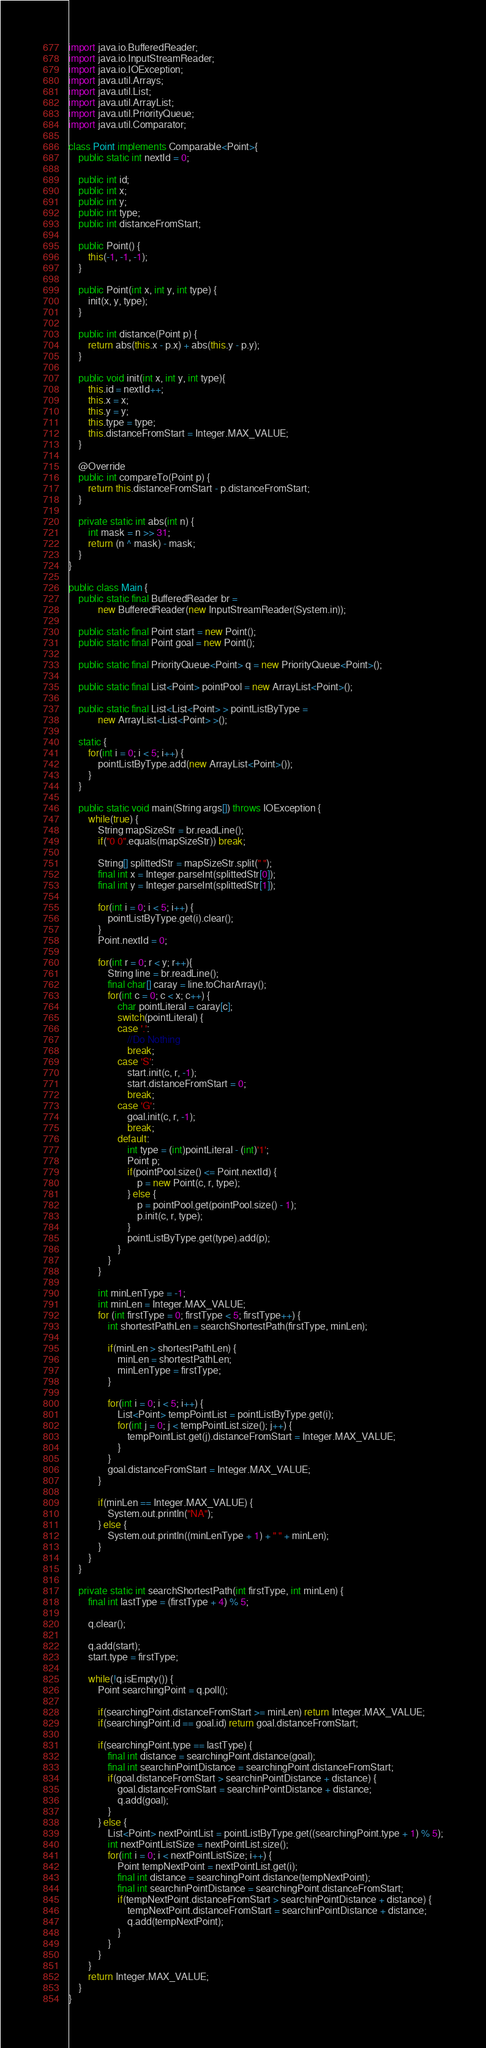Convert code to text. <code><loc_0><loc_0><loc_500><loc_500><_Java_>import java.io.BufferedReader;
import java.io.InputStreamReader;
import java.io.IOException;
import java.util.Arrays;
import java.util.List;
import java.util.ArrayList;
import java.util.PriorityQueue;
import java.util.Comparator;
 
class Point implements Comparable<Point>{
    public static int nextId = 0;
  
    public int id;
    public int x;
    public int y;
    public int type;
    public int distanceFromStart;
    
    public Point() {
        this(-1, -1, -1);
    }
     
    public Point(int x, int y, int type) {
        init(x, y, type);
    }
  
    public int distance(Point p) {
        return abs(this.x - p.x) + abs(this.y - p.y);
    }
     
    public void init(int x, int y, int type){
        this.id = nextId++;
        this.x = x;
        this.y = y;
        this.type = type;
        this.distanceFromStart = Integer.MAX_VALUE;
    }
    
    @Override
    public int compareTo(Point p) {
        return this.distanceFromStart - p.distanceFromStart;
    }
     
    private static int abs(int n) {
        int mask = n >> 31;
        return (n ^ mask) - mask;
    }
}
  
public class Main {
    public static final BufferedReader br =
            new BufferedReader(new InputStreamReader(System.in));
  
    public static final Point start = new Point();
    public static final Point goal = new Point();

    public static final PriorityQueue<Point> q = new PriorityQueue<Point>();
 
    public static final List<Point> pointPool = new ArrayList<Point>();
     
    public static final List<List<Point> > pointListByType =
            new ArrayList<List<Point> >();
     
    static {
        for(int i = 0; i < 5; i++) {
            pointListByType.add(new ArrayList<Point>());
        }
    }
  
    public static void main(String args[]) throws IOException {
        while(true) {
            String mapSizeStr = br.readLine();
            if("0 0".equals(mapSizeStr)) break;
  
            String[] splittedStr = mapSizeStr.split(" ");
            final int x = Integer.parseInt(splittedStr[0]);
            final int y = Integer.parseInt(splittedStr[1]);
                 
            for(int i = 0; i < 5; i++) {
                pointListByType.get(i).clear();
            }
            Point.nextId = 0;
  
            for(int r = 0; r < y; r++){
                String line = br.readLine();
                final char[] caray = line.toCharArray();
                for(int c = 0; c < x; c++) {
                    char pointLiteral = caray[c];
                    switch(pointLiteral) {
                    case '.':
                        //Do Nothing
                        break;
                    case 'S':
                        start.init(c, r, -1);
                        start.distanceFromStart = 0;
                        break;
                    case 'G':
                        goal.init(c, r, -1);
                        break;
                    default:
                        int type = (int)pointLiteral - (int)'1';
                        Point p;
                        if(pointPool.size() <= Point.nextId) {
                            p = new Point(c, r, type);
                        } else {
                            p = pointPool.get(pointPool.size() - 1);
                            p.init(c, r, type);
                        }
                        pointListByType.get(type).add(p);
                    }
                }
            }
  
            int minLenType = -1;
            int minLen = Integer.MAX_VALUE;
            for (int firstType = 0; firstType < 5; firstType++) { 
                int shortestPathLen = searchShortestPath(firstType, minLen);
  
                if(minLen > shortestPathLen) {
                    minLen = shortestPathLen;
                    minLenType = firstType;
                }
  
                for(int i = 0; i < 5; i++) {
                    List<Point> tempPointList = pointListByType.get(i);
                    for(int j = 0; j < tempPointList.size(); j++) {
                        tempPointList.get(j).distanceFromStart = Integer.MAX_VALUE;
                    }
                }
                goal.distanceFromStart = Integer.MAX_VALUE;
            }
  
            if(minLen == Integer.MAX_VALUE) {
                System.out.println("NA");
            } else {
                System.out.println((minLenType + 1) + " " + minLen);
            }
        }
    }
  
    private static int searchShortestPath(int firstType, int minLen) {
        final int lastType = (firstType + 4) % 5;
            
        q.clear();
  
        q.add(start);
        start.type = firstType;
           
        while(!q.isEmpty()) {
            Point searchingPoint = q.poll();

            if(searchingPoint.distanceFromStart >= minLen) return Integer.MAX_VALUE;
            if(searchingPoint.id == goal.id) return goal.distanceFromStart;

            if(searchingPoint.type == lastType) {
                final int distance = searchingPoint.distance(goal);
                final int searchinPointDistance = searchingPoint.distanceFromStart;
                if(goal.distanceFromStart > searchinPointDistance + distance) {
                    goal.distanceFromStart = searchinPointDistance + distance;
                    q.add(goal);
                }
            } else {
                List<Point> nextPointList = pointListByType.get((searchingPoint.type + 1) % 5);
                int nextPointListSize = nextPointList.size();
                for(int i = 0; i < nextPointListSize; i++) {
                    Point tempNextPoint = nextPointList.get(i);
                    final int distance = searchingPoint.distance(tempNextPoint);
                    final int searchinPointDistance = searchingPoint.distanceFromStart;
                    if(tempNextPoint.distanceFromStart > searchinPointDistance + distance) {
                        tempNextPoint.distanceFromStart = searchinPointDistance + distance;
                        q.add(tempNextPoint);
                    }
                }
            }
        }
        return Integer.MAX_VALUE;
    }
}   </code> 